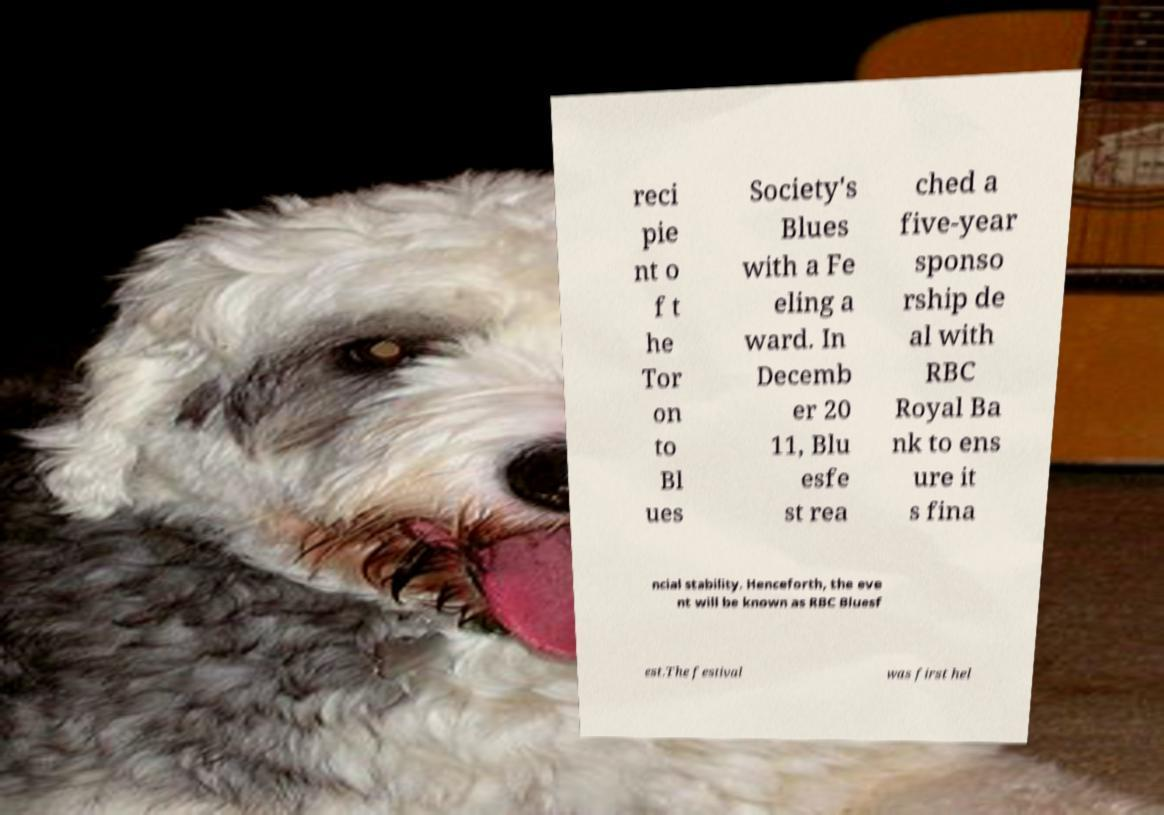Can you read and provide the text displayed in the image?This photo seems to have some interesting text. Can you extract and type it out for me? reci pie nt o f t he Tor on to Bl ues Society's Blues with a Fe eling a ward. In Decemb er 20 11, Blu esfe st rea ched a five-year sponso rship de al with RBC Royal Ba nk to ens ure it s fina ncial stability. Henceforth, the eve nt will be known as RBC Bluesf est.The festival was first hel 